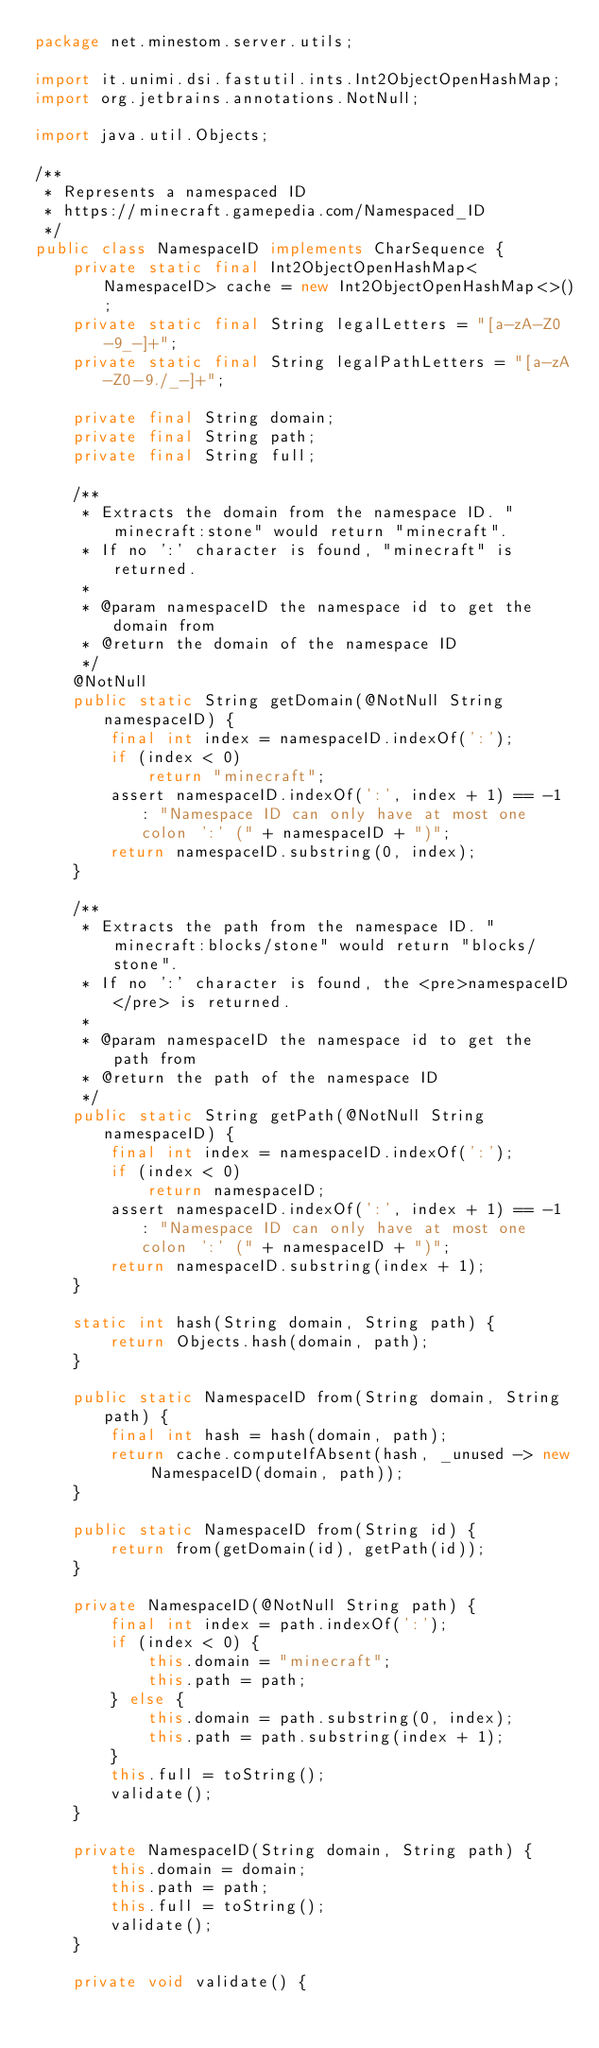Convert code to text. <code><loc_0><loc_0><loc_500><loc_500><_Java_>package net.minestom.server.utils;

import it.unimi.dsi.fastutil.ints.Int2ObjectOpenHashMap;
import org.jetbrains.annotations.NotNull;

import java.util.Objects;

/**
 * Represents a namespaced ID
 * https://minecraft.gamepedia.com/Namespaced_ID
 */
public class NamespaceID implements CharSequence {
    private static final Int2ObjectOpenHashMap<NamespaceID> cache = new Int2ObjectOpenHashMap<>();
    private static final String legalLetters = "[a-zA-Z0-9_-]+";
    private static final String legalPathLetters = "[a-zA-Z0-9./_-]+";

    private final String domain;
    private final String path;
    private final String full;

    /**
     * Extracts the domain from the namespace ID. "minecraft:stone" would return "minecraft".
     * If no ':' character is found, "minecraft" is returned.
     *
     * @param namespaceID the namespace id to get the domain from
     * @return the domain of the namespace ID
     */
    @NotNull
    public static String getDomain(@NotNull String namespaceID) {
        final int index = namespaceID.indexOf(':');
        if (index < 0)
            return "minecraft";
        assert namespaceID.indexOf(':', index + 1) == -1 : "Namespace ID can only have at most one colon ':' (" + namespaceID + ")";
        return namespaceID.substring(0, index);
    }

    /**
     * Extracts the path from the namespace ID. "minecraft:blocks/stone" would return "blocks/stone".
     * If no ':' character is found, the <pre>namespaceID</pre> is returned.
     *
     * @param namespaceID the namespace id to get the path from
     * @return the path of the namespace ID
     */
    public static String getPath(@NotNull String namespaceID) {
        final int index = namespaceID.indexOf(':');
        if (index < 0)
            return namespaceID;
        assert namespaceID.indexOf(':', index + 1) == -1 : "Namespace ID can only have at most one colon ':' (" + namespaceID + ")";
        return namespaceID.substring(index + 1);
    }

    static int hash(String domain, String path) {
        return Objects.hash(domain, path);
    }

    public static NamespaceID from(String domain, String path) {
        final int hash = hash(domain, path);
        return cache.computeIfAbsent(hash, _unused -> new NamespaceID(domain, path));
    }

    public static NamespaceID from(String id) {
        return from(getDomain(id), getPath(id));
    }

    private NamespaceID(@NotNull String path) {
        final int index = path.indexOf(':');
        if (index < 0) {
            this.domain = "minecraft";
            this.path = path;
        } else {
            this.domain = path.substring(0, index);
            this.path = path.substring(index + 1);
        }
        this.full = toString();
        validate();
    }

    private NamespaceID(String domain, String path) {
        this.domain = domain;
        this.path = path;
        this.full = toString();
        validate();
    }

    private void validate() {</code> 